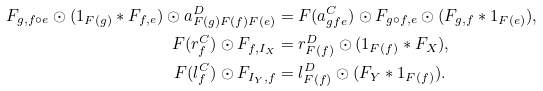<formula> <loc_0><loc_0><loc_500><loc_500>F _ { g , f \circ e } \odot ( 1 _ { F ( g ) } * F _ { f , e } ) \odot a ^ { D } _ { F ( g ) F ( f ) F ( e ) } & = F ( a ^ { C } _ { g f e } ) \odot F _ { g \circ f , e } \odot ( F _ { g , f } * 1 _ { F ( e ) } ) , \\ F ( r ^ { C } _ { f } ) \odot F _ { f , I _ { X } } & = r ^ { D } _ { F ( f ) } \odot ( 1 _ { F ( f ) } * F _ { X } ) , \\ F ( l ^ { C } _ { f } ) \odot F _ { I _ { Y } , f } & = l ^ { D } _ { F ( f ) } \odot ( F _ { Y } * 1 _ { F ( f ) } ) .</formula> 